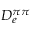Convert formula to latex. <formula><loc_0><loc_0><loc_500><loc_500>D _ { e } ^ { \pi \pi }</formula> 